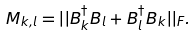Convert formula to latex. <formula><loc_0><loc_0><loc_500><loc_500>M _ { k , l } = | | B _ { k } ^ { \dagger } B _ { l } + B _ { l } ^ { \dagger } B _ { k } | | _ { F } .</formula> 